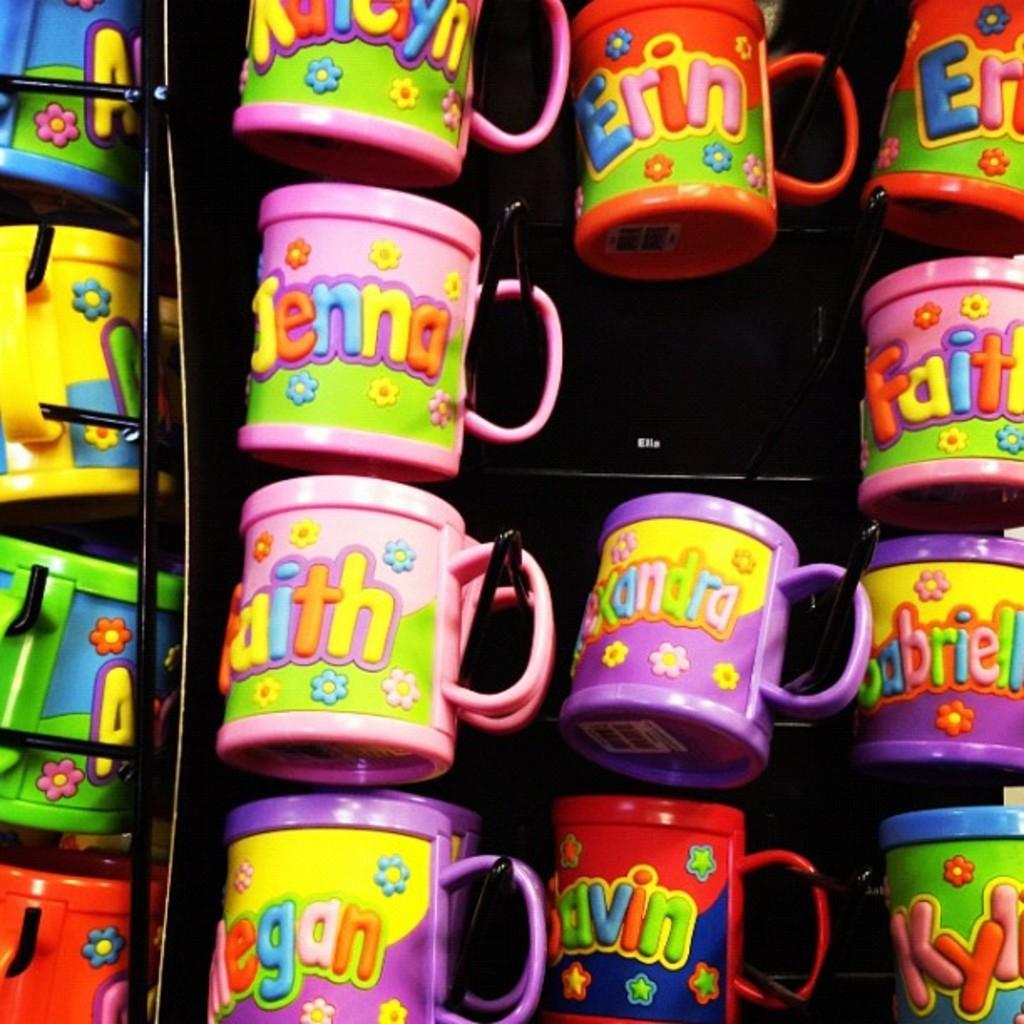Describe this image in one or two sentences. In this image there are cups with different colors like pink, purple, red, blue, yellow. 